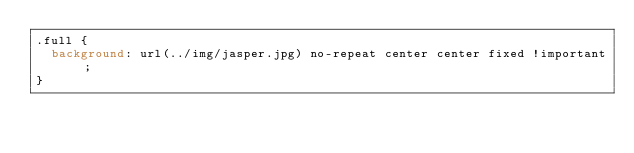<code> <loc_0><loc_0><loc_500><loc_500><_CSS_>.full {
  background: url(../img/jasper.jpg) no-repeat center center fixed !important; 
}</code> 